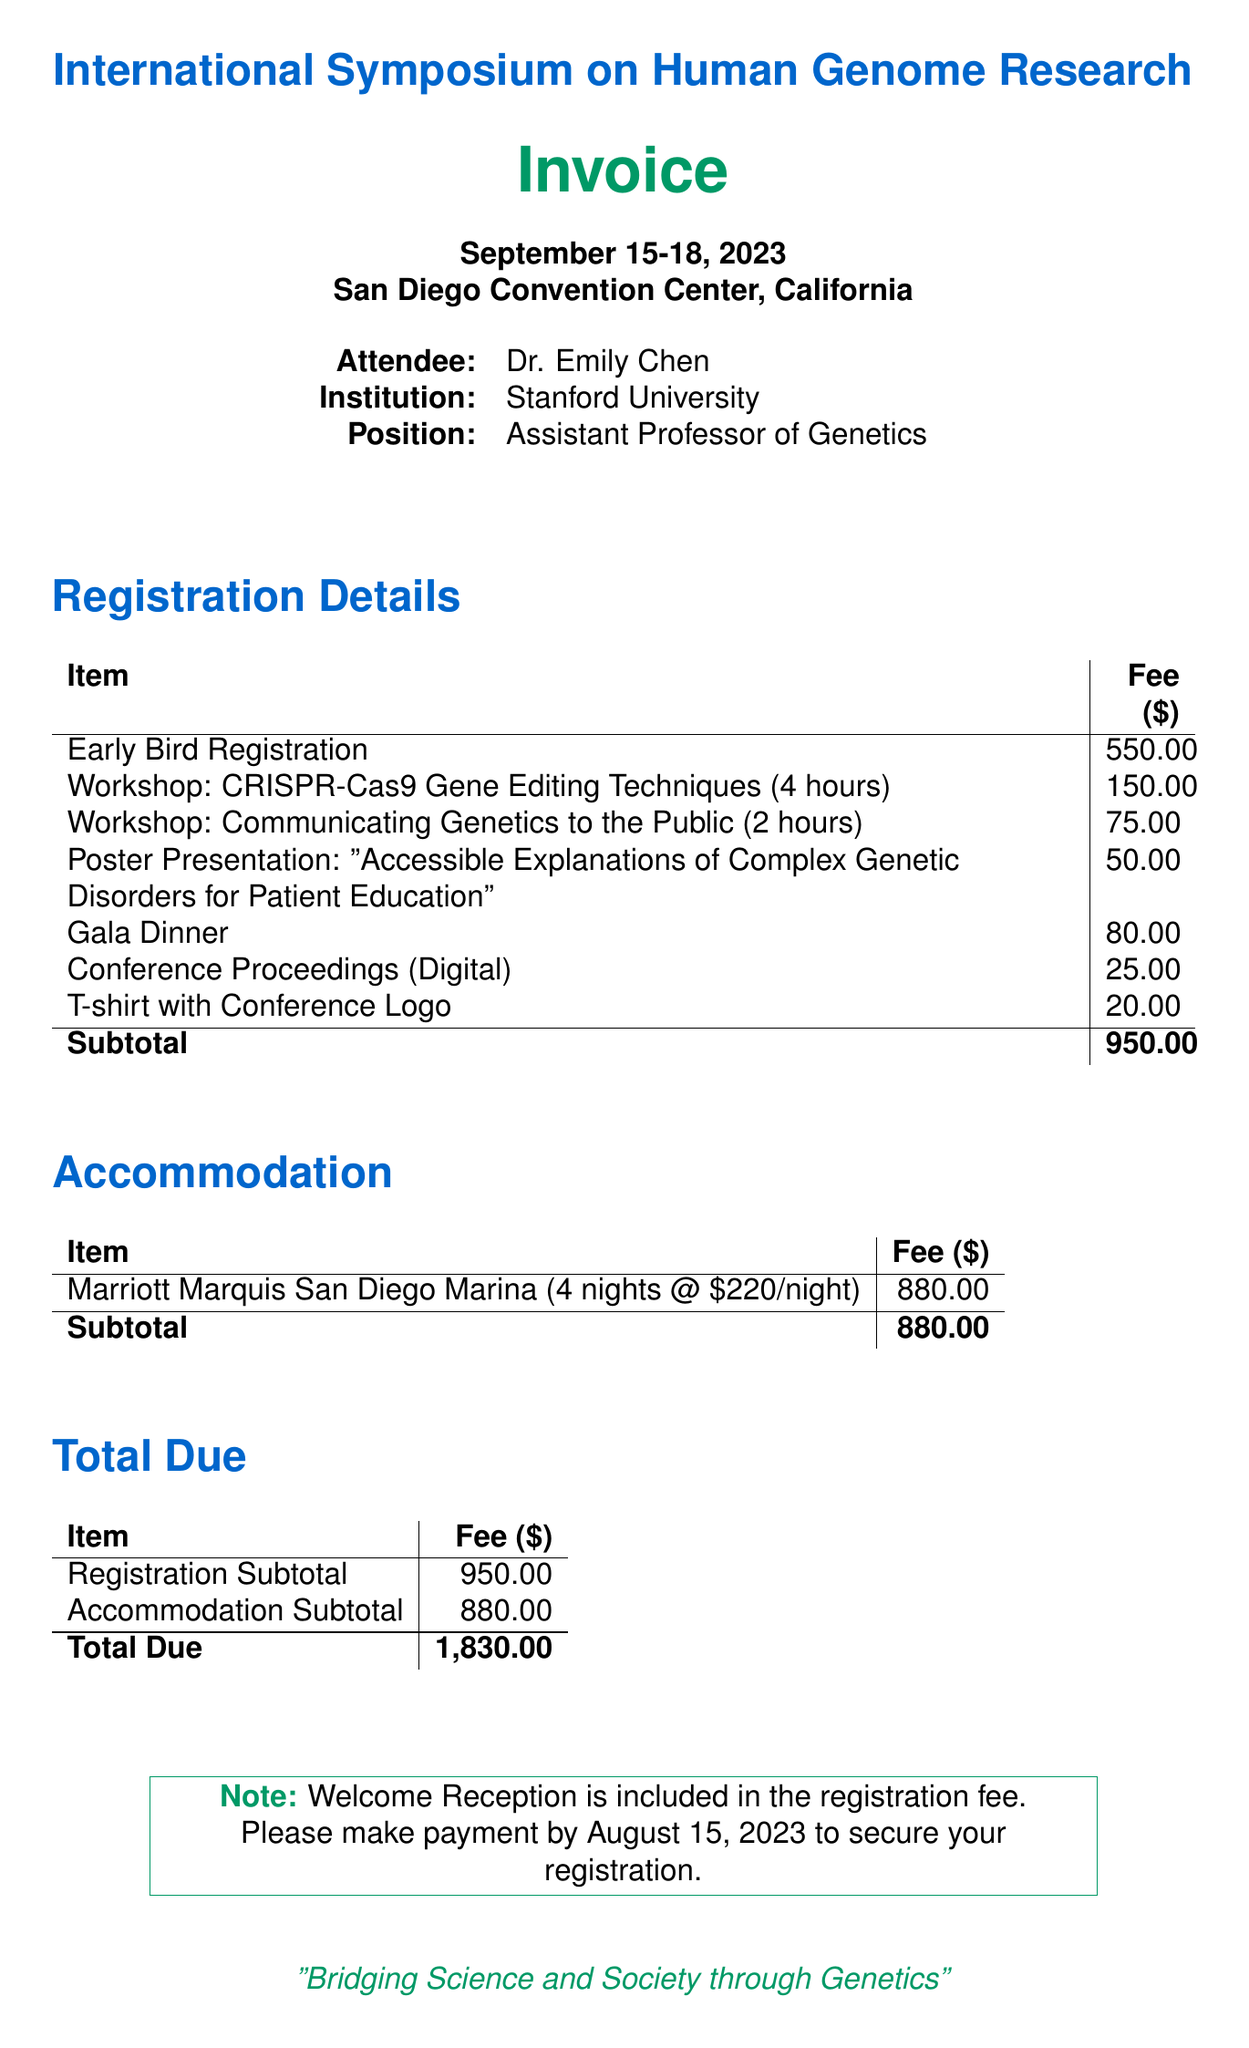What is the name of the conference? The conference is titled "International Symposium on Human Genome Research."
Answer: International Symposium on Human Genome Research What are the dates of the conference? The conference is taking place from September 15 to September 18, 2023.
Answer: September 15-18, 2023 Who is the attendee? The invoice lists Dr. Emily Chen as the attendee.
Answer: Dr. Emily Chen What is the fee for the CRISPR-Cas9 workshop? The fee for the CRISPR-Cas9 workshop is specified as $150.
Answer: 150 What is the total due amount for the registration and accommodation? The total due amount calculated in the document is $1,830.
Answer: 1,830 What is included in the registration fee? The document notes that the Welcome Reception is included in the registration fee.
Answer: Welcome Reception How many nights of accommodation are booked? The accommodation section indicates that 4 nights are booked.
Answer: 4 What is the submission fee for the poster presentation? The submission fee for the poster presentation is stated as $50.
Answer: 50 What is the location of the conference? The location of the conference is the San Diego Convention Center, California.
Answer: San Diego Convention Center, California 